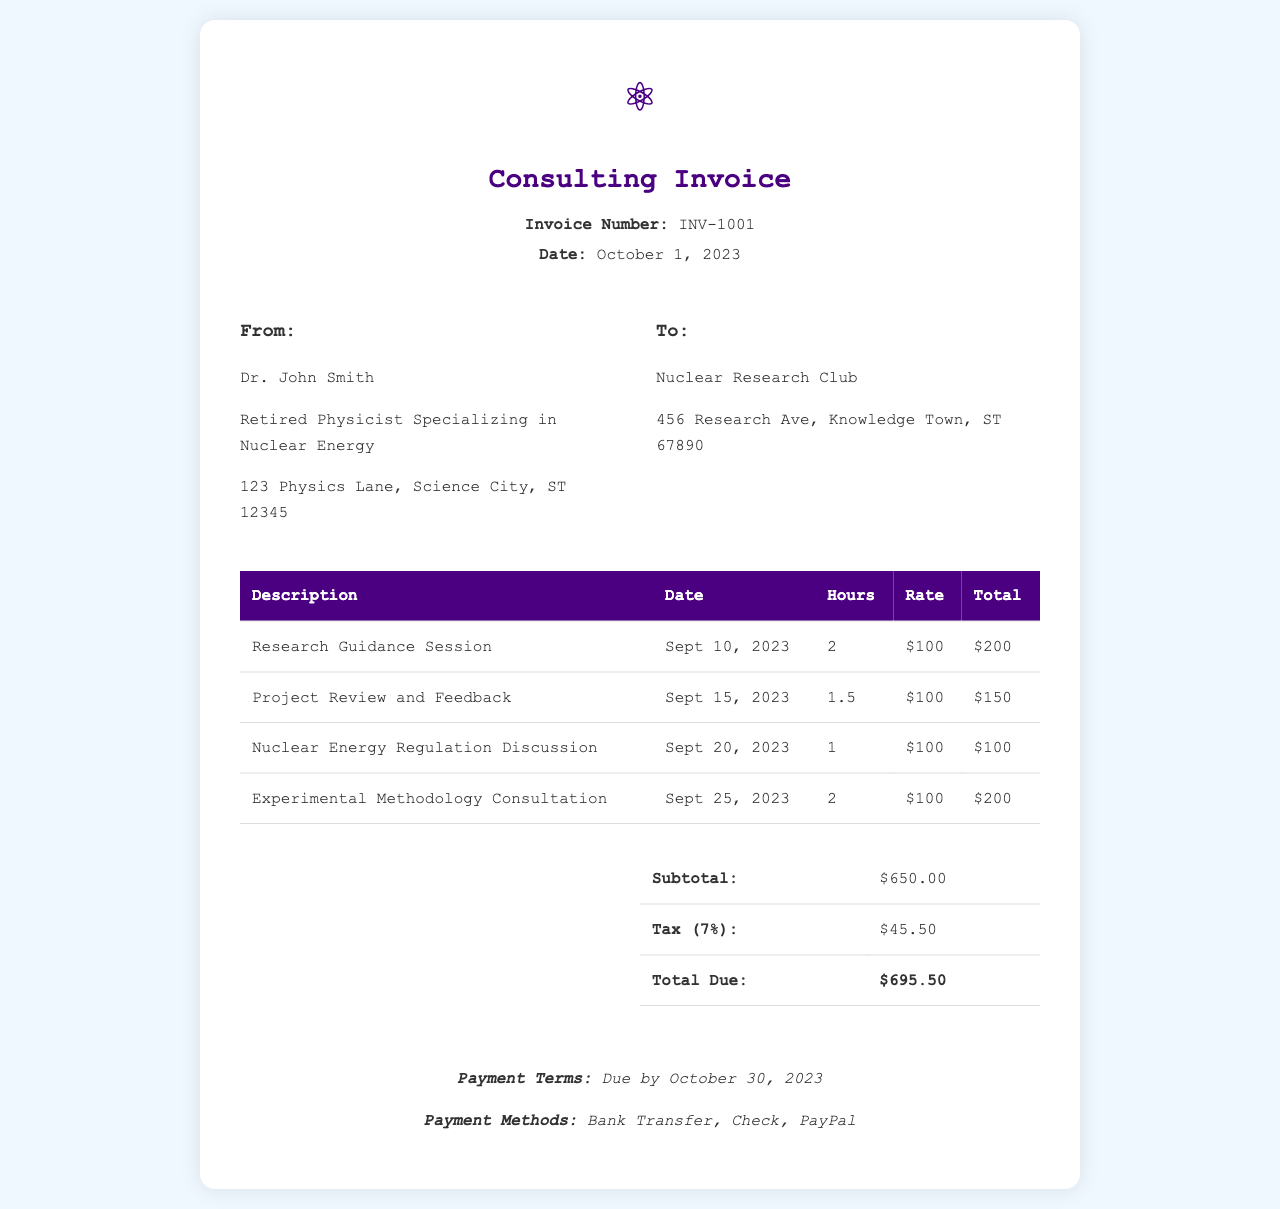What is the invoice number? The invoice number is clearly stated in the header of the document.
Answer: INV-1001 What is the date of the invoice? The date of the invoice is also mentioned in the header section of the document.
Answer: October 1, 2023 Who provided the consulting services? The provider of the consulting services is identified in the "From" section of the invoice.
Answer: Dr. John Smith What is the total due amount? The total due amount can be found in the summary section of the invoice.
Answer: $695.50 What was the hourly rate for consulting services? The rate is specified for each service in the table detailing the hours worked.
Answer: $100 How many hours were worked for the Experimental Methodology Consultation? The hours worked are displayed in the corresponding row of the table.
Answer: 2 What is the subtotal before tax? The subtotal appears in the summary table and reflects the total before tax is applied.
Answer: $650.00 What is the payment due date? The payment terms section specifies the due date for payment.
Answer: October 30, 2023 How much tax was applied to the invoice? The tax amount is detailed in the summary table, showing the tax calculation.
Answer: $45.50 